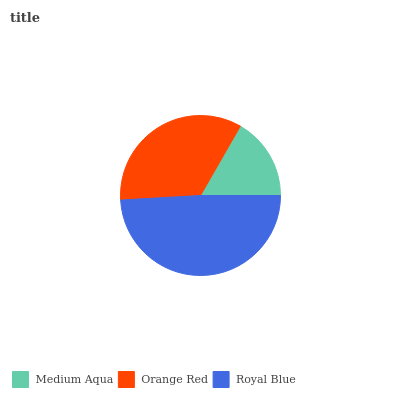Is Medium Aqua the minimum?
Answer yes or no. Yes. Is Royal Blue the maximum?
Answer yes or no. Yes. Is Orange Red the minimum?
Answer yes or no. No. Is Orange Red the maximum?
Answer yes or no. No. Is Orange Red greater than Medium Aqua?
Answer yes or no. Yes. Is Medium Aqua less than Orange Red?
Answer yes or no. Yes. Is Medium Aqua greater than Orange Red?
Answer yes or no. No. Is Orange Red less than Medium Aqua?
Answer yes or no. No. Is Orange Red the high median?
Answer yes or no. Yes. Is Orange Red the low median?
Answer yes or no. Yes. Is Medium Aqua the high median?
Answer yes or no. No. Is Medium Aqua the low median?
Answer yes or no. No. 